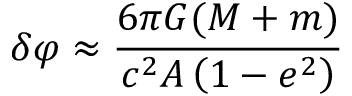<formula> <loc_0><loc_0><loc_500><loc_500>\delta \varphi \approx { \frac { 6 \pi G ( M + m ) } { c ^ { 2 } A \left ( 1 - e ^ { 2 } \right ) } }</formula> 